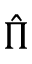<formula> <loc_0><loc_0><loc_500><loc_500>\hat { \Pi }</formula> 